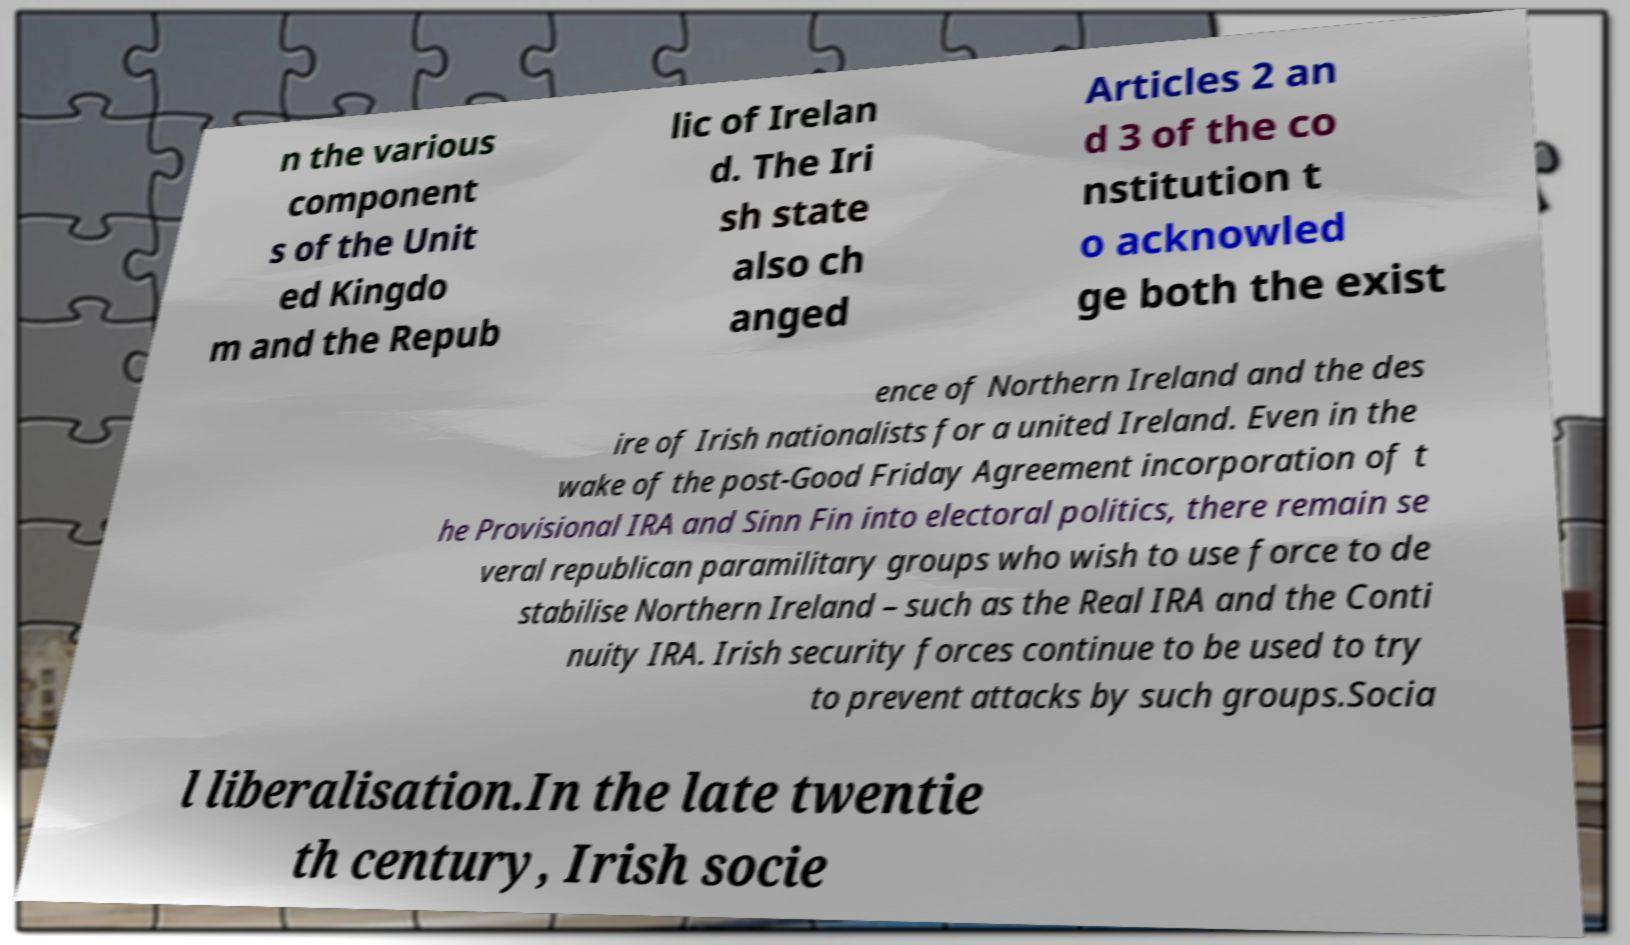Please identify and transcribe the text found in this image. n the various component s of the Unit ed Kingdo m and the Repub lic of Irelan d. The Iri sh state also ch anged Articles 2 an d 3 of the co nstitution t o acknowled ge both the exist ence of Northern Ireland and the des ire of Irish nationalists for a united Ireland. Even in the wake of the post-Good Friday Agreement incorporation of t he Provisional IRA and Sinn Fin into electoral politics, there remain se veral republican paramilitary groups who wish to use force to de stabilise Northern Ireland – such as the Real IRA and the Conti nuity IRA. Irish security forces continue to be used to try to prevent attacks by such groups.Socia l liberalisation.In the late twentie th century, Irish socie 